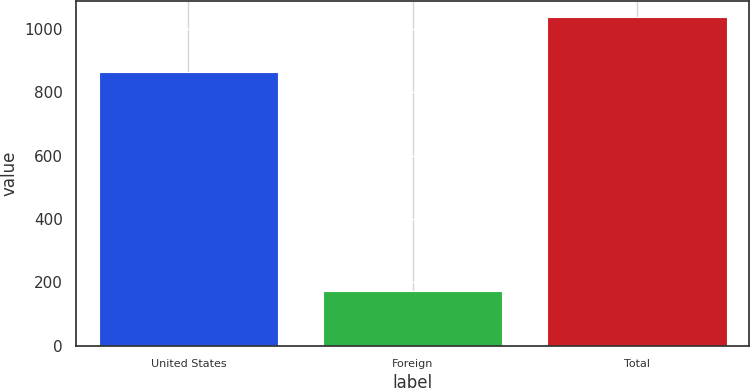Convert chart. <chart><loc_0><loc_0><loc_500><loc_500><bar_chart><fcel>United States<fcel>Foreign<fcel>Total<nl><fcel>864<fcel>173<fcel>1037<nl></chart> 